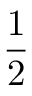Convert formula to latex. <formula><loc_0><loc_0><loc_500><loc_500>\frac { 1 } { 2 }</formula> 